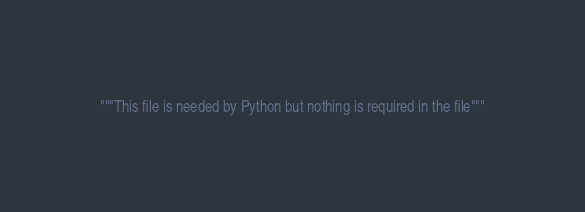<code> <loc_0><loc_0><loc_500><loc_500><_Python_>"""This file is needed by Python but nothing is required in the file"""
</code> 